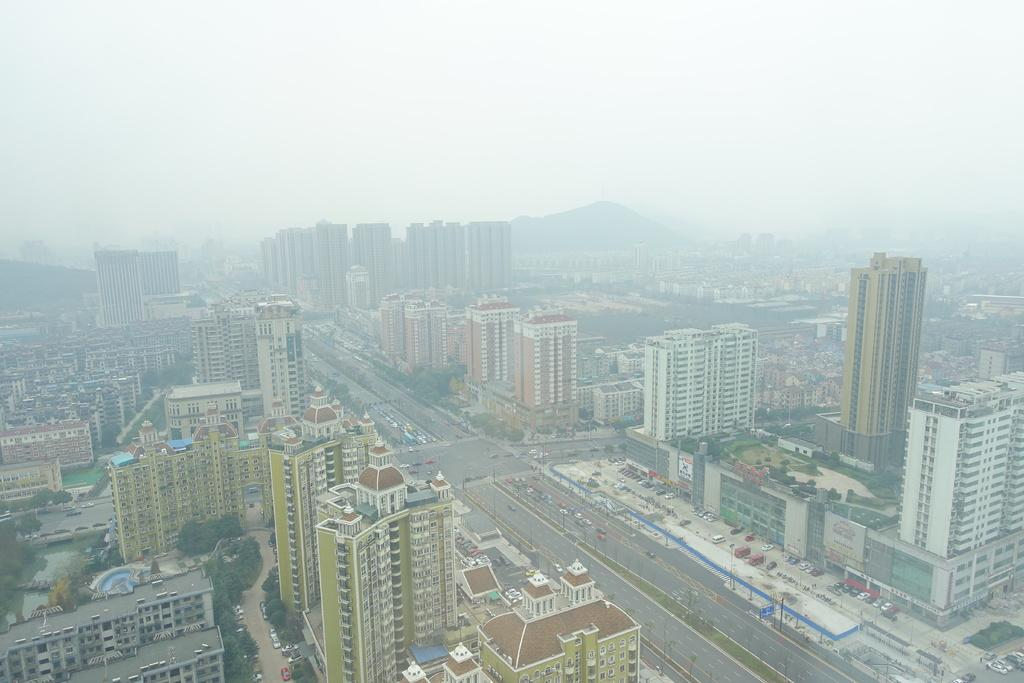What type of view is shown in the image? The image is an aerial view. What structures can be seen in the image? There are buildings in the image. What type of natural elements are present in the image? There are trees and mountains in the image. What man-made elements can be seen in the image? There are roads and vehicles in the image. What rhythm is being played by the trees in the image? There is no rhythm being played by the trees in the image, as trees do not produce music or rhythm. 